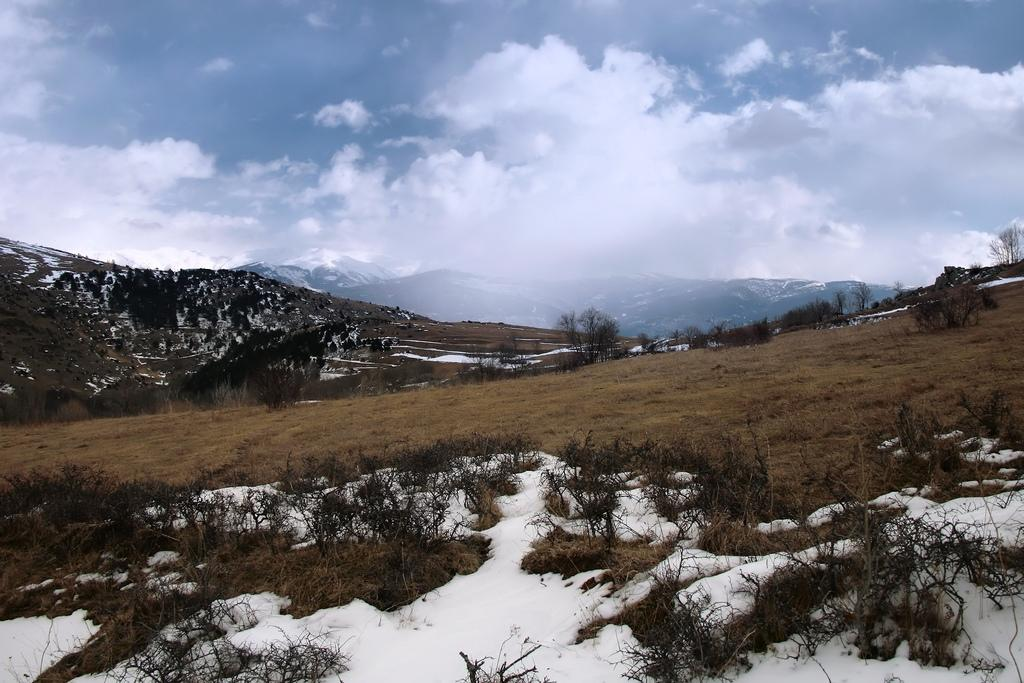What type of landscape is shown in the image? The image depicts a mountain area. What is the condition of the mountain area in the image? The mountain area is covered with snow. What can be seen in the background of the image? There are mountains visible in the background of the image, and the sky is also visible. Where is the sink located in the image? There is no sink present in the image; it is a mountain landscape covered with snow. Can you see any fish swimming in the snow in the image? There are no fish present in the image, as it is a mountain landscape covered with snow. 